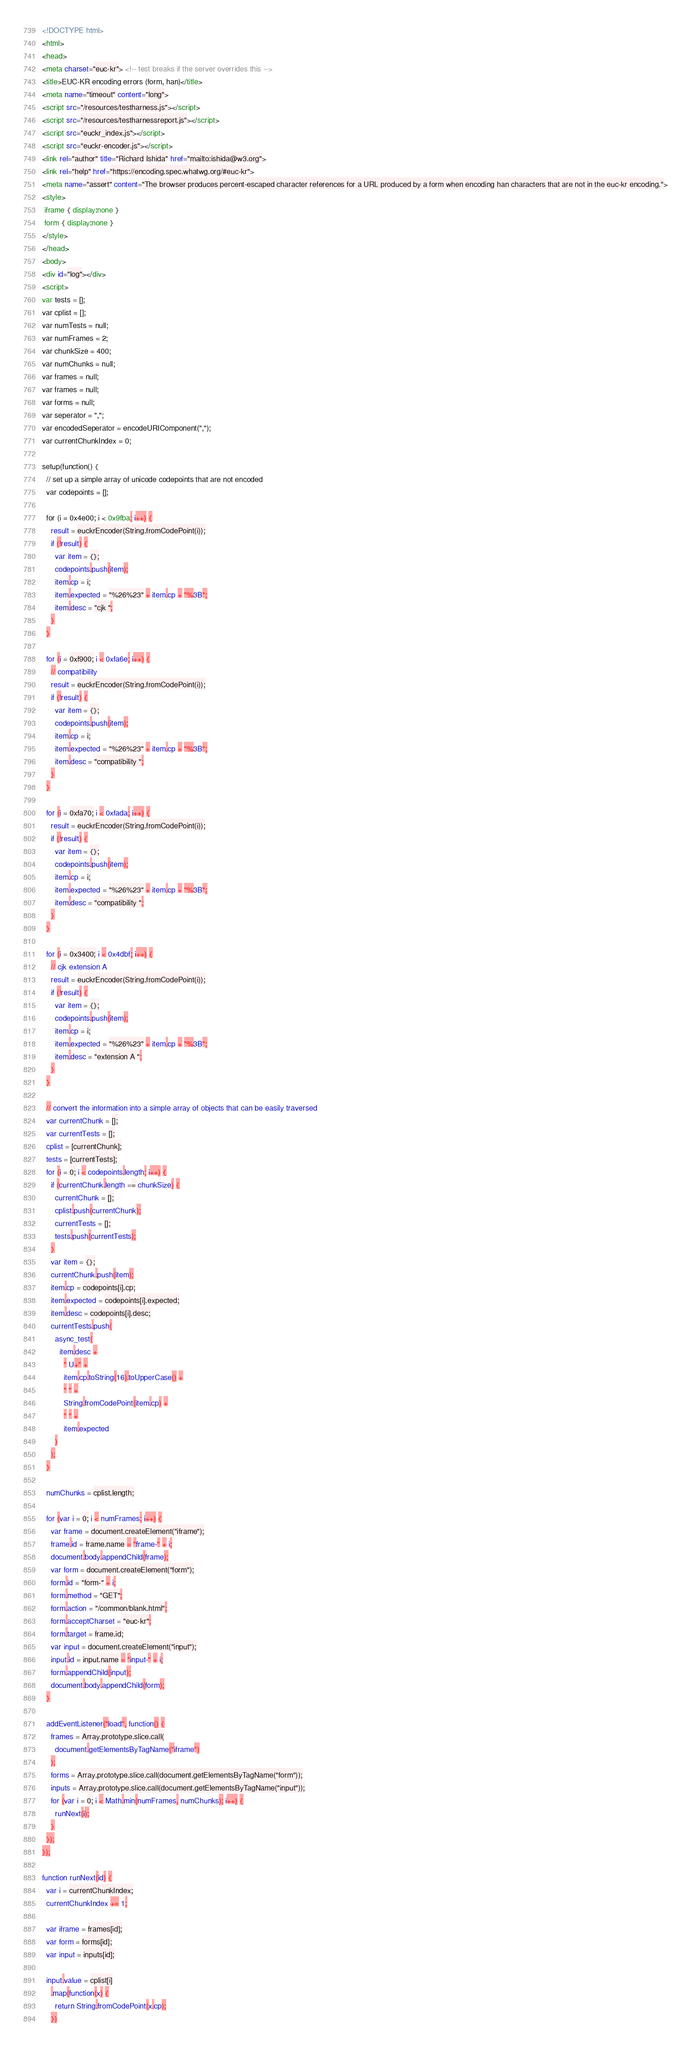<code> <loc_0><loc_0><loc_500><loc_500><_HTML_><!DOCTYPE html>
<html>
<head>
<meta charset="euc-kr"> <!-- test breaks if the server overrides this -->
<title>EUC-KR encoding errors (form, han)</title>
<meta name="timeout" content="long">
<script src="/resources/testharness.js"></script>
<script src="/resources/testharnessreport.js"></script>
<script src="euckr_index.js"></script>
<script src="euckr-encoder.js"></script>
<link rel="author" title="Richard Ishida" href="mailto:ishida@w3.org">
<link rel="help" href="https://encoding.spec.whatwg.org/#euc-kr">
<meta name="assert" content="The browser produces percent-escaped character references for a URL produced by a form when encoding han characters that are not in the euc-kr encoding.">
<style>
 iframe { display:none }
 form { display:none }
</style>
</head>
<body>
<div id="log"></div>
<script>
var tests = [];
var cplist = [];
var numTests = null;
var numFrames = 2;
var chunkSize = 400;
var numChunks = null;
var frames = null;
var frames = null;
var forms = null;
var seperator = ",";
var encodedSeperator = encodeURIComponent(",");
var currentChunkIndex = 0;

setup(function() {
  // set up a simple array of unicode codepoints that are not encoded
  var codepoints = [];

  for (i = 0x4e00; i < 0x9fba; i++) {
    result = euckrEncoder(String.fromCodePoint(i));
    if (!result) {
      var item = {};
      codepoints.push(item);
      item.cp = i;
      item.expected = "%26%23" + item.cp + "%3B";
      item.desc = "cjk ";
    }
  }

  for (i = 0xf900; i < 0xfa6e; i++) {
    // compatibility
    result = euckrEncoder(String.fromCodePoint(i));
    if (!result) {
      var item = {};
      codepoints.push(item);
      item.cp = i;
      item.expected = "%26%23" + item.cp + "%3B";
      item.desc = "compatibility ";
    }
  }

  for (i = 0xfa70; i < 0xfada; i++) {
    result = euckrEncoder(String.fromCodePoint(i));
    if (!result) {
      var item = {};
      codepoints.push(item);
      item.cp = i;
      item.expected = "%26%23" + item.cp + "%3B";
      item.desc = "compatibility ";
    }
  }

  for (i = 0x3400; i < 0x4dbf; i++) {
    // cjk extension A
    result = euckrEncoder(String.fromCodePoint(i));
    if (!result) {
      var item = {};
      codepoints.push(item);
      item.cp = i;
      item.expected = "%26%23" + item.cp + "%3B";
      item.desc = "extension A ";
    }
  }

  // convert the information into a simple array of objects that can be easily traversed
  var currentChunk = [];
  var currentTests = [];
  cplist = [currentChunk];
  tests = [currentTests];
  for (i = 0; i < codepoints.length; i++) {
    if (currentChunk.length == chunkSize) {
      currentChunk = [];
      cplist.push(currentChunk);
      currentTests = [];
      tests.push(currentTests);
    }
    var item = {};
    currentChunk.push(item);
    item.cp = codepoints[i].cp;
    item.expected = codepoints[i].expected;
    item.desc = codepoints[i].desc;
    currentTests.push(
      async_test(
        item.desc +
          " U+" +
          item.cp.toString(16).toUpperCase() +
          " " +
          String.fromCodePoint(item.cp) +
          " " +
          item.expected
      )
    );
  }

  numChunks = cplist.length;

  for (var i = 0; i < numFrames; i++) {
    var frame = document.createElement("iframe");
    frame.id = frame.name = "frame-" + i;
    document.body.appendChild(frame);
    var form = document.createElement("form");
    form.id = "form-" + i;
    form.method = "GET";
    form.action = "/common/blank.html";
    form.acceptCharset = "euc-kr";
    form.target = frame.id;
    var input = document.createElement("input");
    input.id = input.name = "input-" + i;
    form.appendChild(input);
    document.body.appendChild(form);
  }

  addEventListener("load", function() {
    frames = Array.prototype.slice.call(
      document.getElementsByTagName("iframe")
    );
    forms = Array.prototype.slice.call(document.getElementsByTagName("form"));
    inputs = Array.prototype.slice.call(document.getElementsByTagName("input"));
    for (var i = 0; i < Math.min(numFrames, numChunks); i++) {
      runNext(i);
    }
  });
});

function runNext(id) {
  var i = currentChunkIndex;
  currentChunkIndex += 1;

  var iframe = frames[id];
  var form = forms[id];
  var input = inputs[id];

  input.value = cplist[i]
    .map(function(x) {
      return String.fromCodePoint(x.cp);
    })</code> 